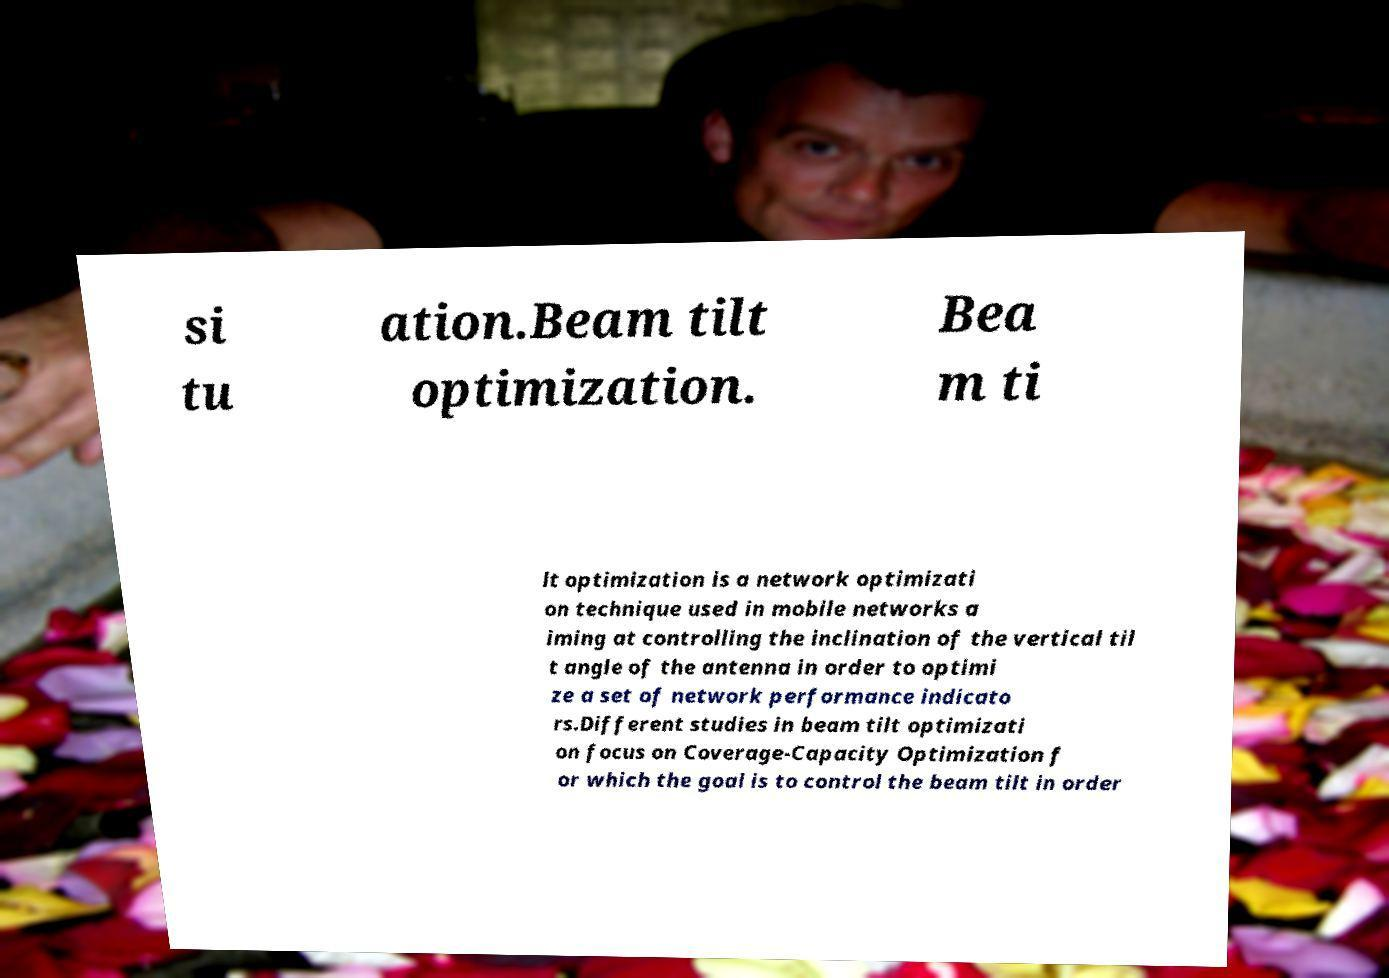For documentation purposes, I need the text within this image transcribed. Could you provide that? si tu ation.Beam tilt optimization. Bea m ti lt optimization is a network optimizati on technique used in mobile networks a iming at controlling the inclination of the vertical til t angle of the antenna in order to optimi ze a set of network performance indicato rs.Different studies in beam tilt optimizati on focus on Coverage-Capacity Optimization f or which the goal is to control the beam tilt in order 